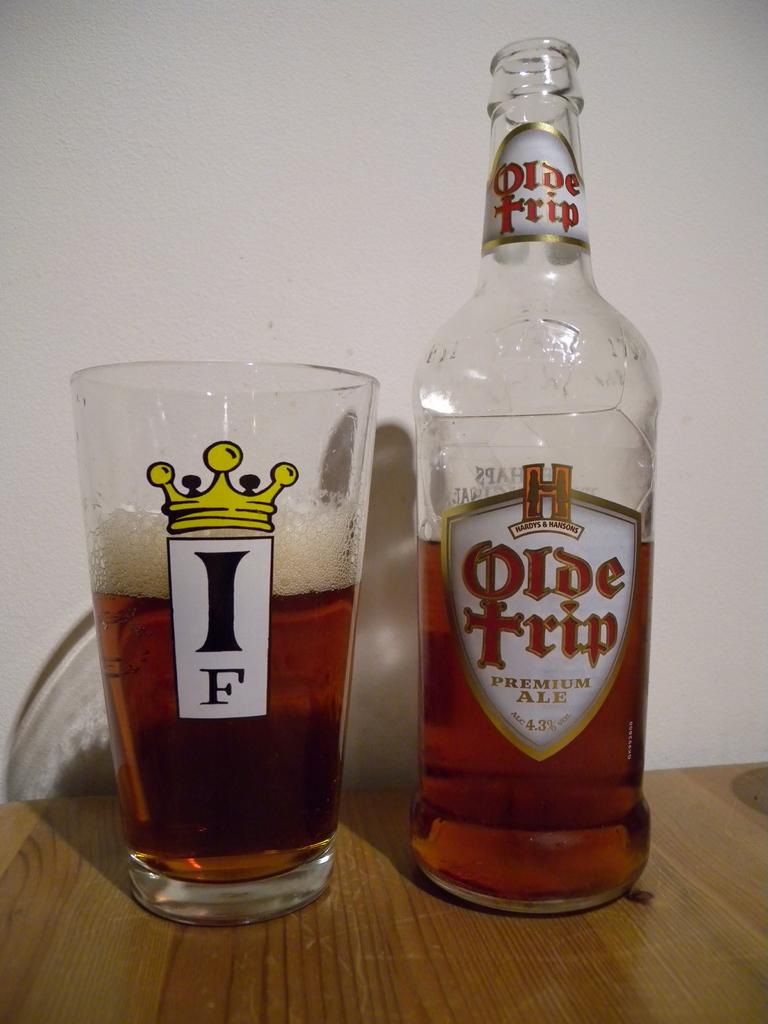<image>
Give a short and clear explanation of the subsequent image. a bottle of Olde tripe Premium Ale and a glass of it next to it. 